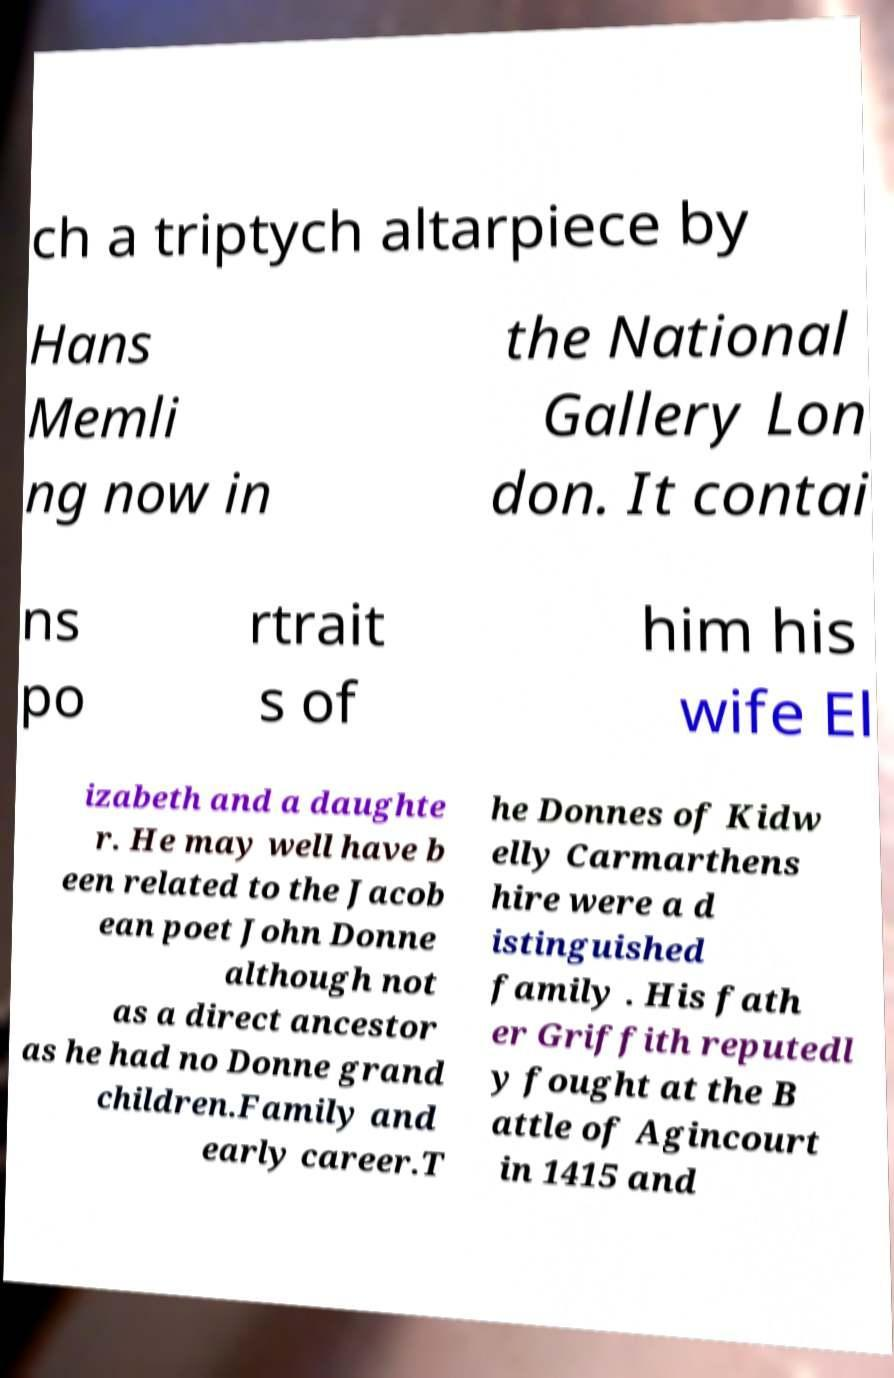Can you read and provide the text displayed in the image?This photo seems to have some interesting text. Can you extract and type it out for me? ch a triptych altarpiece by Hans Memli ng now in the National Gallery Lon don. It contai ns po rtrait s of him his wife El izabeth and a daughte r. He may well have b een related to the Jacob ean poet John Donne although not as a direct ancestor as he had no Donne grand children.Family and early career.T he Donnes of Kidw elly Carmarthens hire were a d istinguished family . His fath er Griffith reputedl y fought at the B attle of Agincourt in 1415 and 